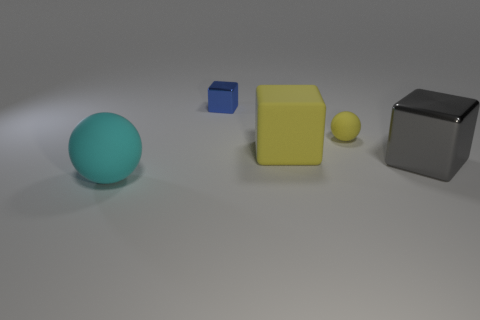Add 1 tiny yellow spheres. How many objects exist? 6 Subtract all balls. How many objects are left? 3 Add 2 brown metal balls. How many brown metal balls exist? 2 Subtract 0 purple spheres. How many objects are left? 5 Subtract all big yellow rubber spheres. Subtract all tiny blue blocks. How many objects are left? 4 Add 4 small blue metal blocks. How many small blue metal blocks are left? 5 